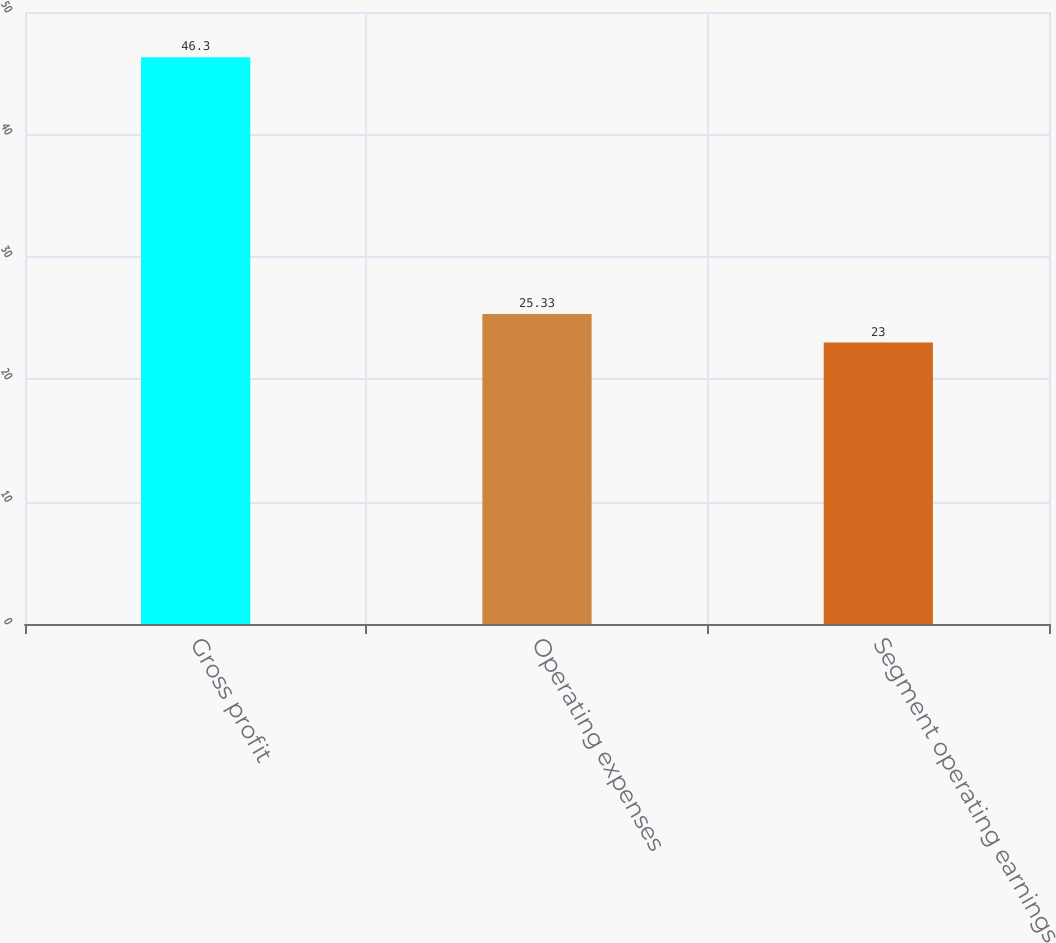Convert chart. <chart><loc_0><loc_0><loc_500><loc_500><bar_chart><fcel>Gross profit<fcel>Operating expenses<fcel>Segment operating earnings<nl><fcel>46.3<fcel>25.33<fcel>23<nl></chart> 